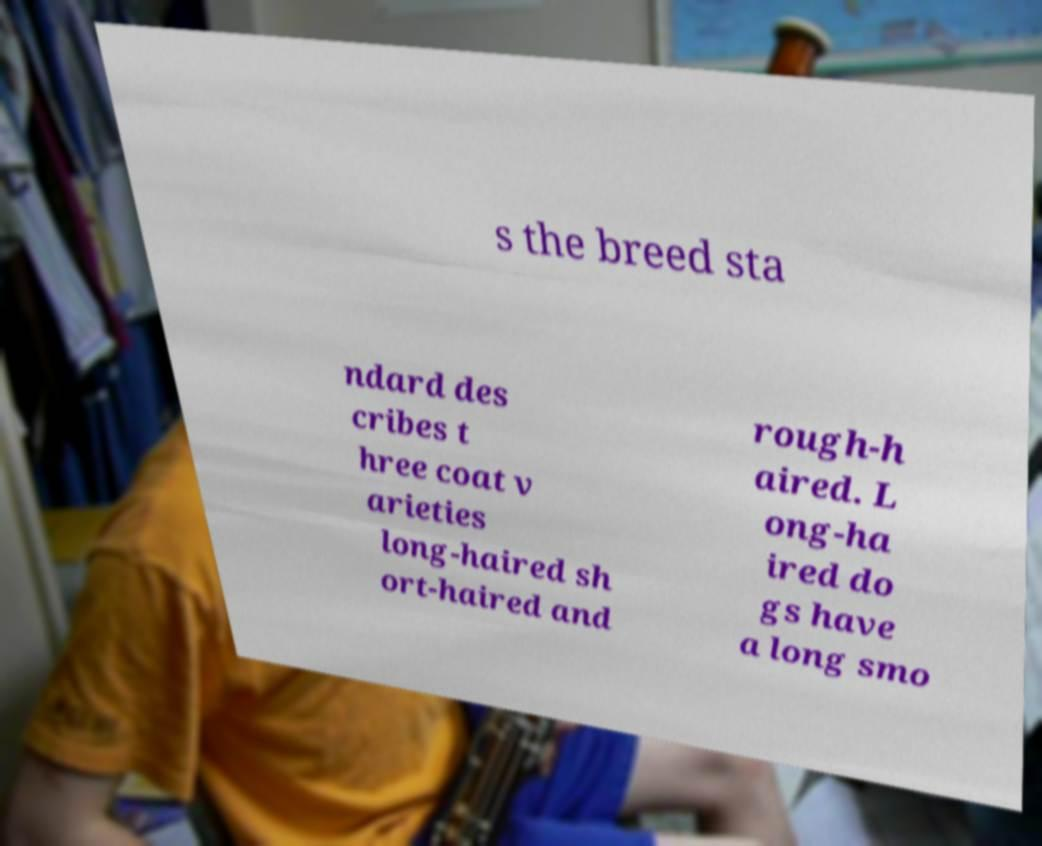I need the written content from this picture converted into text. Can you do that? s the breed sta ndard des cribes t hree coat v arieties long-haired sh ort-haired and rough-h aired. L ong-ha ired do gs have a long smo 